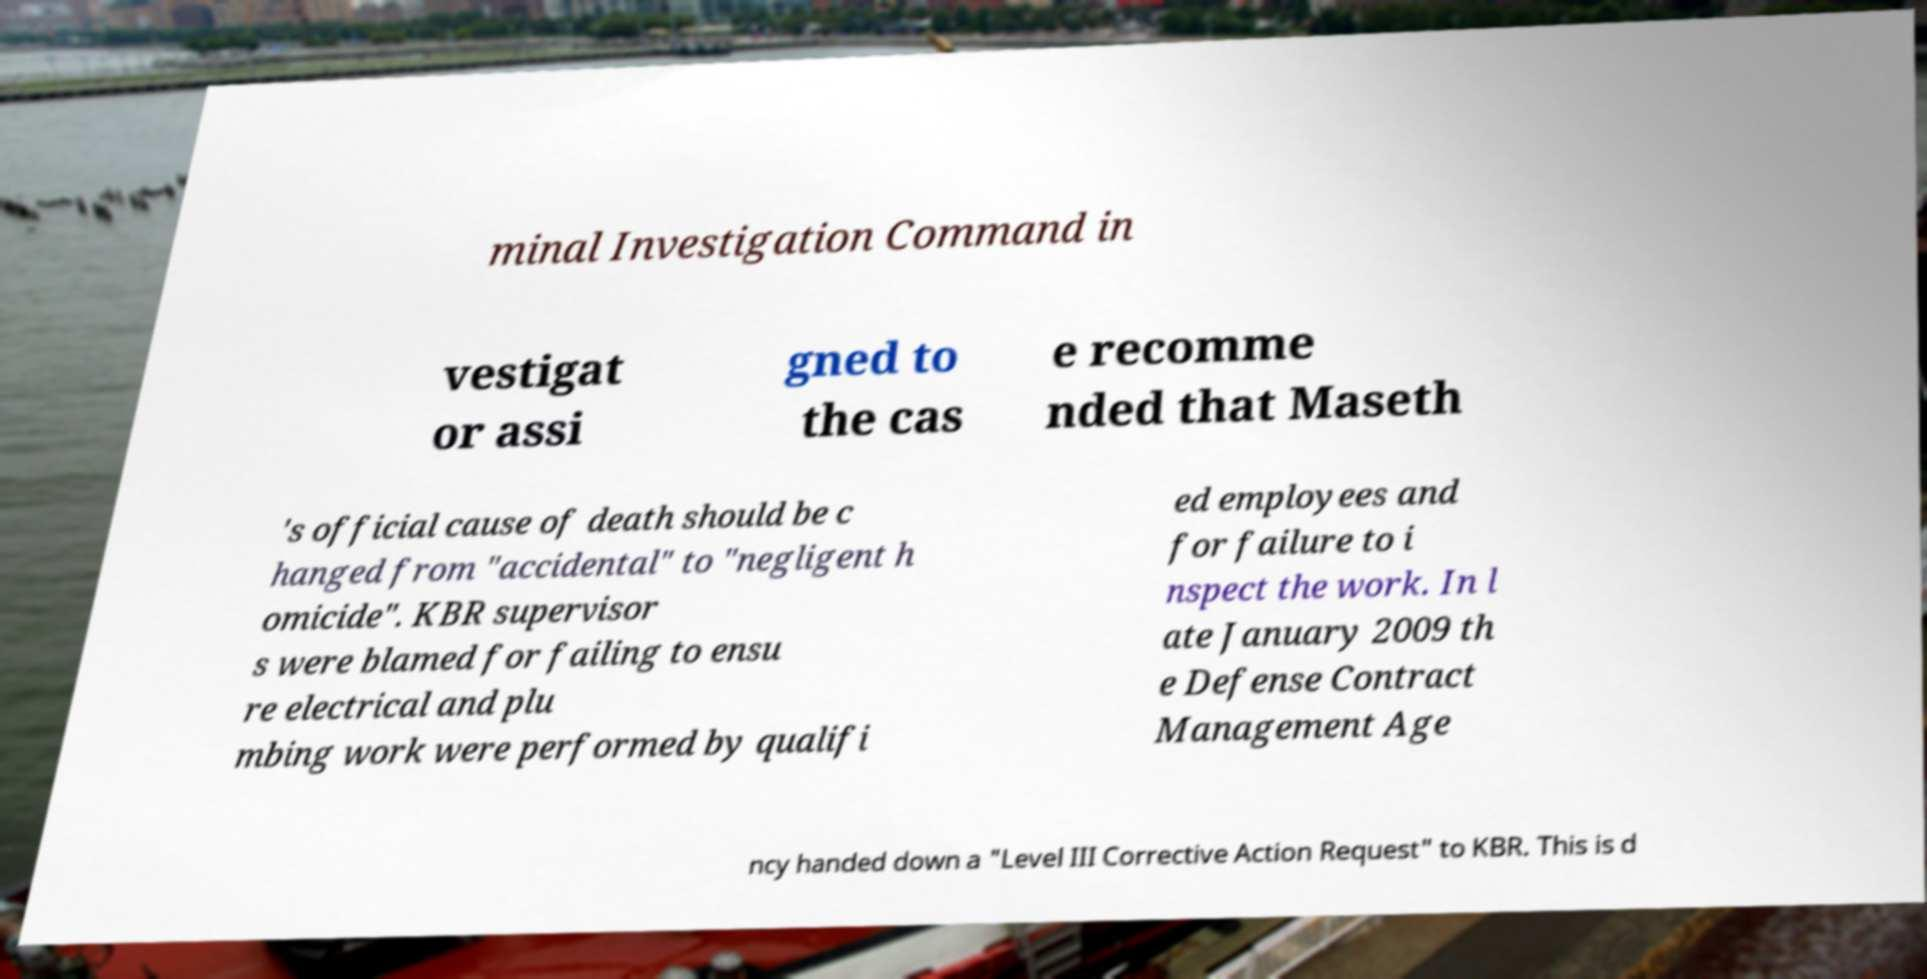Please identify and transcribe the text found in this image. minal Investigation Command in vestigat or assi gned to the cas e recomme nded that Maseth 's official cause of death should be c hanged from "accidental" to "negligent h omicide". KBR supervisor s were blamed for failing to ensu re electrical and plu mbing work were performed by qualifi ed employees and for failure to i nspect the work. In l ate January 2009 th e Defense Contract Management Age ncy handed down a "Level III Corrective Action Request" to KBR. This is d 